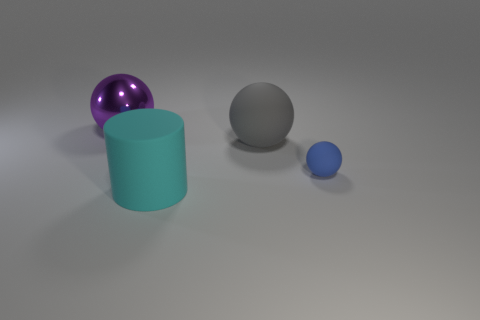Add 3 cyan rubber cylinders. How many objects exist? 7 Subtract all cylinders. How many objects are left? 3 Subtract 0 yellow spheres. How many objects are left? 4 Subtract all large metallic spheres. Subtract all tiny blue matte spheres. How many objects are left? 2 Add 3 blue balls. How many blue balls are left? 4 Add 1 green metal spheres. How many green metal spheres exist? 1 